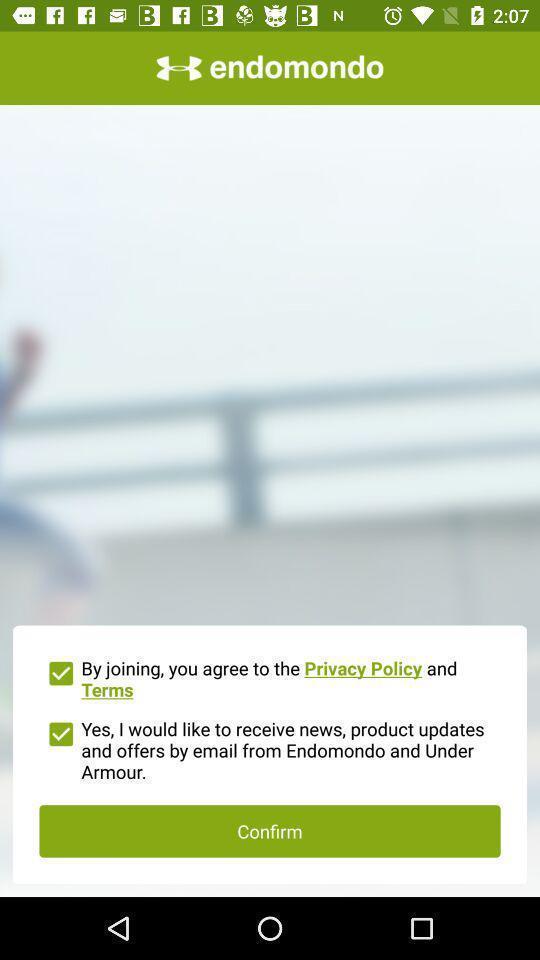Describe the key features of this screenshot. Window displaying an workout app. 